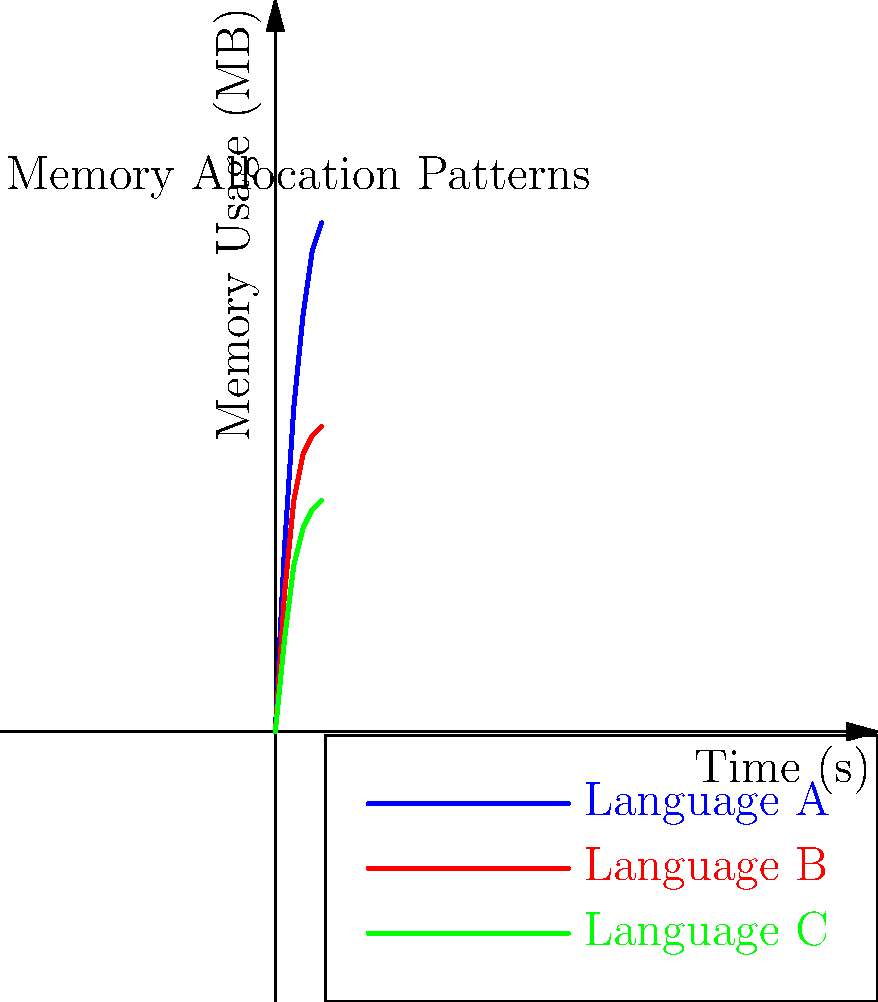Based on the memory allocation chart provided, which programming language demonstrates the most efficient memory management for long-running processes, and what optimization technique might be responsible for this behavior? To answer this question, we need to analyze the memory usage patterns of the three languages shown in the chart:

1. Observe the curves:
   - Language A (blue): Rapid initial growth, then slowing but continuing to increase
   - Language B (red): Moderate initial growth, then leveling off
   - Language C (green): Slow initial growth, then minimal increase

2. Consider long-running processes:
   - For extended runtimes, we're interested in the behavior as time approaches infinity
   - Language C shows the least growth over time, indicating the best memory management for long-running processes

3. Analyze potential optimization techniques:
   - Language C's pattern suggests efficient garbage collection or memory reuse
   - The minimal increase after initial allocation indicates good memory pooling or object reuse

4. Compare with other languages:
   - Language A shows potential memory leaks or inefficient allocation
   - Language B has better management than A but not as efficient as C

5. Conclude based on the data:
   - Language C demonstrates the most efficient memory management for long-running processes
   - The likely optimization technique is efficient garbage collection combined with memory pooling
Answer: Language C; efficient garbage collection and memory pooling 